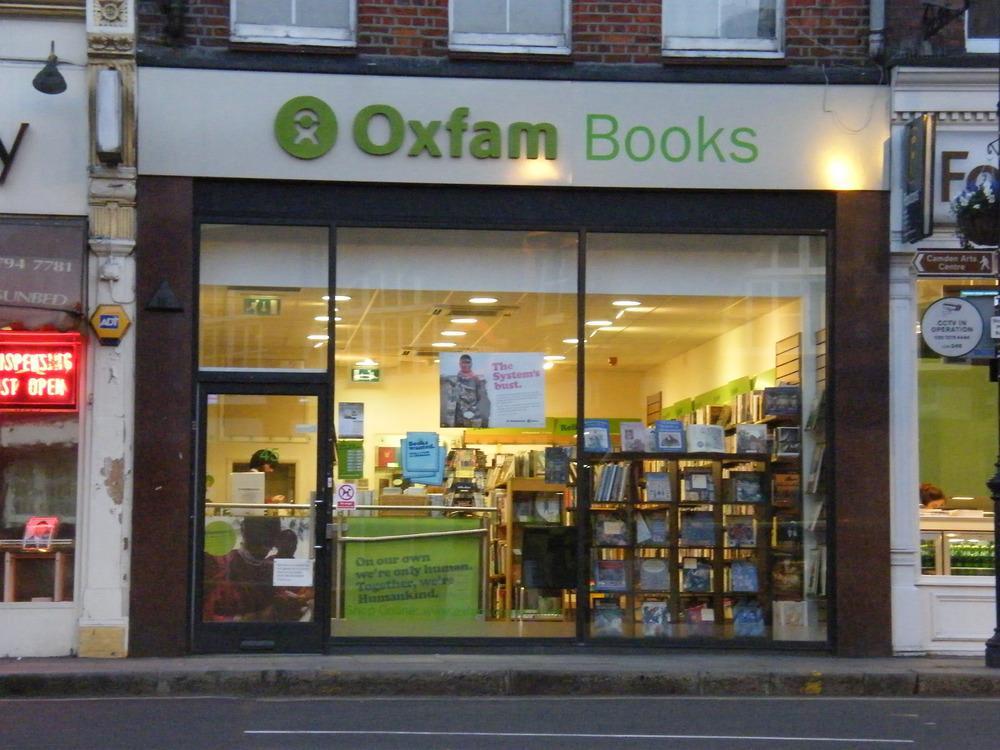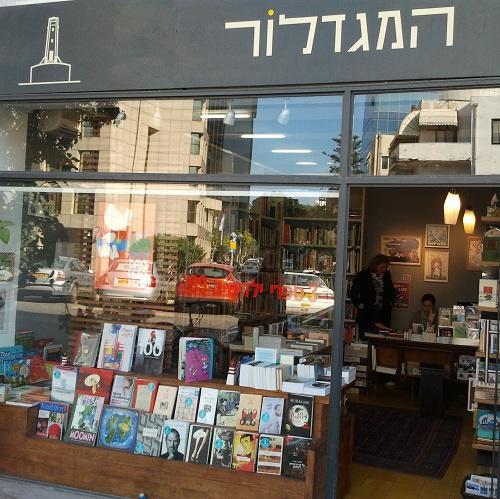The first image is the image on the left, the second image is the image on the right. For the images shown, is this caption "Both images show merchandise displayed inside an exterior window." true? Answer yes or no. Yes. 